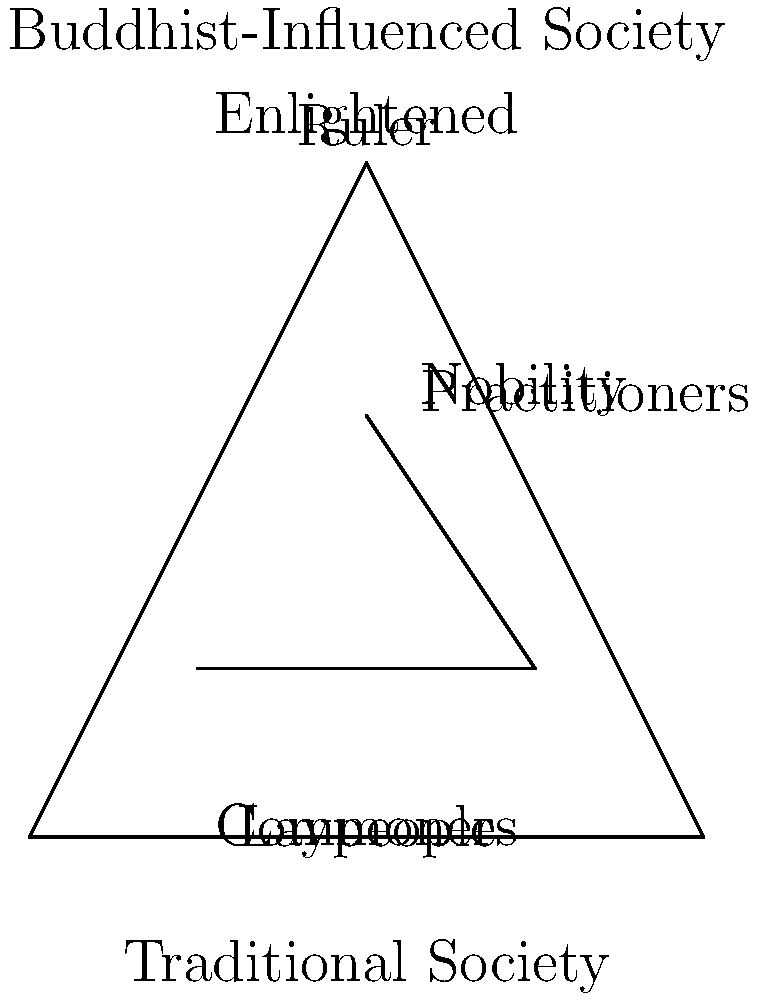Analyze the pyramid diagrams representing traditional and Buddhist-influenced social hierarchies. How does Buddhist philosophy potentially transform the concept of social stratification, and what implications does this have for power dynamics within a society? To answer this question, we need to examine the differences between the two pyramid structures and consider the core principles of Buddhist philosophy:

1. Traditional hierarchy:
   - Rigid structure with clear divisions
   - Power concentrated at the top (Ruler)
   - Limited mobility between social classes

2. Buddhist-influenced hierarchy:
   - More fluid structure with less defined boundaries
   - Emphasis on spiritual attainment rather than inherited status
   - Potential for mobility based on individual practice and enlightenment

3. Buddhist principles affecting social structure:
   - Equality: Buddha taught that all beings have the potential for enlightenment
   - Non-attachment: Discourages clinging to worldly status and possessions
   - Karma and rebirth: Suggests that one's current status is not permanent

4. Transformation of social stratification:
   - Shift from birth-based to merit-based hierarchy
   - Emphasis on spiritual development rather than material wealth or political power
   - Potential for individuals to move between social strata through practice

5. Implications for power dynamics:
   - Decentralization of power from political rulers to spiritual leaders
   - Increased social mobility based on individual effort and spiritual attainment
   - Potential for more egalitarian social structures and decision-making processes

6. Challenges and limitations:
   - Traditional power structures may resist change
   - Interpretation and implementation of Buddhist principles can vary
   - Potential for new forms of hierarchy based on perceived spiritual attainment

In conclusion, Buddhist philosophy has the potential to transform social hierarchies by emphasizing spiritual development over inherited status, promoting equality, and encouraging social mobility based on individual practice and enlightenment. This can lead to more fluid power dynamics and potentially more egalitarian societies, although the extent of this transformation may vary depending on how Buddhist principles are interpreted and implemented within different cultural contexts.
Answer: Buddhist philosophy transforms social hierarchies by emphasizing spiritual attainment over inherited status, promoting equality and social mobility based on individual practice, potentially leading to more fluid and egalitarian power dynamics in society. 